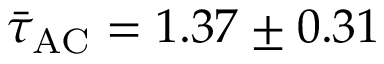Convert formula to latex. <formula><loc_0><loc_0><loc_500><loc_500>\bar { \tau } _ { A C } = 1 . 3 7 \pm 0 . 3 1</formula> 